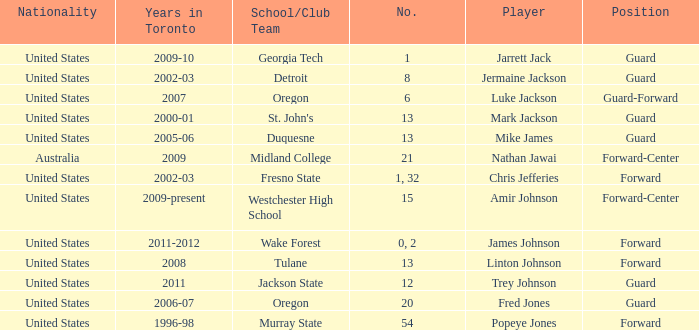What are the nationality of the players on the Fresno State school/club team? United States. 